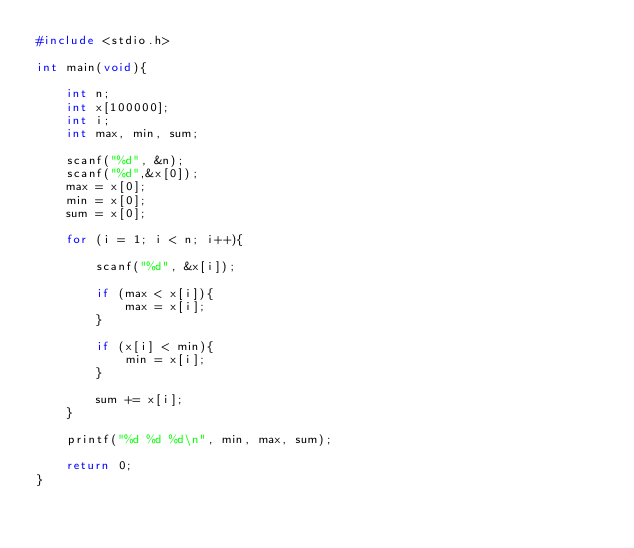<code> <loc_0><loc_0><loc_500><loc_500><_C_>#include <stdio.h>

int main(void){

	int n;
	int x[100000];
	int i;
	int max, min, sum;

	scanf("%d", &n);
	scanf("%d",&x[0]);
	max = x[0];
	min = x[0];
	sum = x[0];

	for (i = 1; i < n; i++){

		scanf("%d", &x[i]);

		if (max < x[i]){
			max = x[i];
		}

		if (x[i] < min){
			min = x[i];
		}

		sum += x[i];
	}

	printf("%d %d %d\n", min, max, sum);

	return 0;
}</code> 